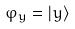Convert formula to latex. <formula><loc_0><loc_0><loc_500><loc_500>\varphi _ { y } = | y \rangle</formula> 